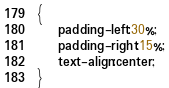Convert code to text. <code><loc_0><loc_0><loc_500><loc_500><_CSS_>{
	padding-left:30%;
	padding-right:15%;
	text-align:center;
}</code> 